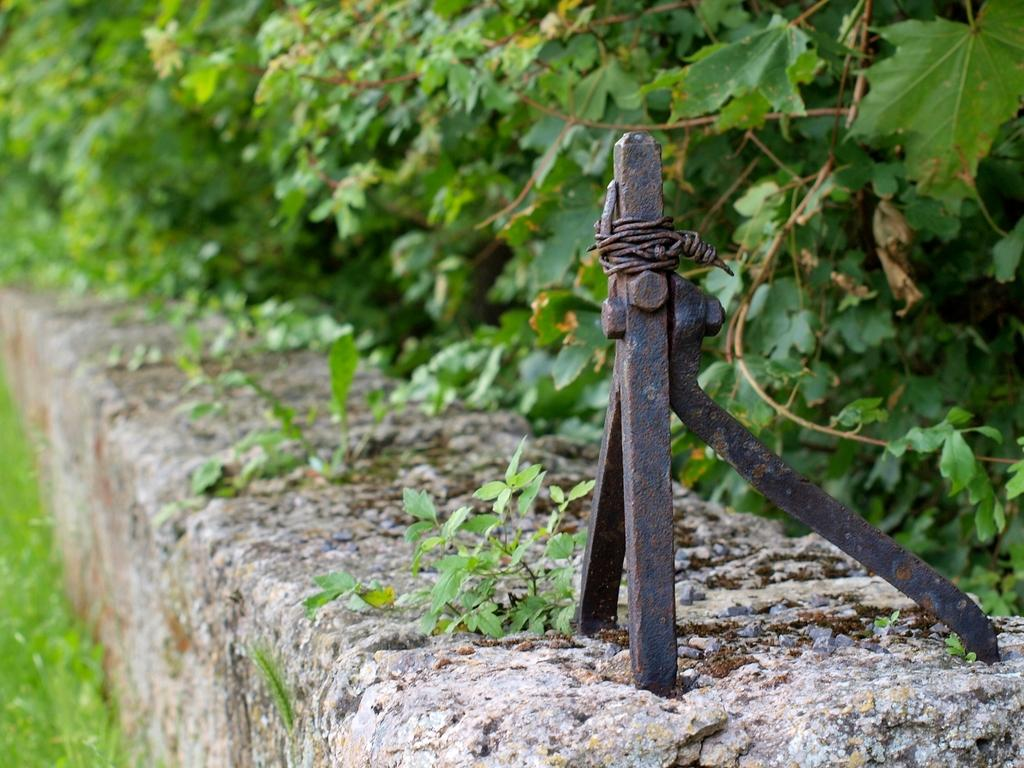What type of object can be seen on the wall in the image? There is a metal object on the wall in the image. What type of vegetation is present in the image? Leaves and grass are visible in the image. How would you describe the background of the image? The background of the image is slightly blurred. How many legs can be seen on the cart in the image? There is no cart present in the image, so it is not possible to determine the number of legs. 